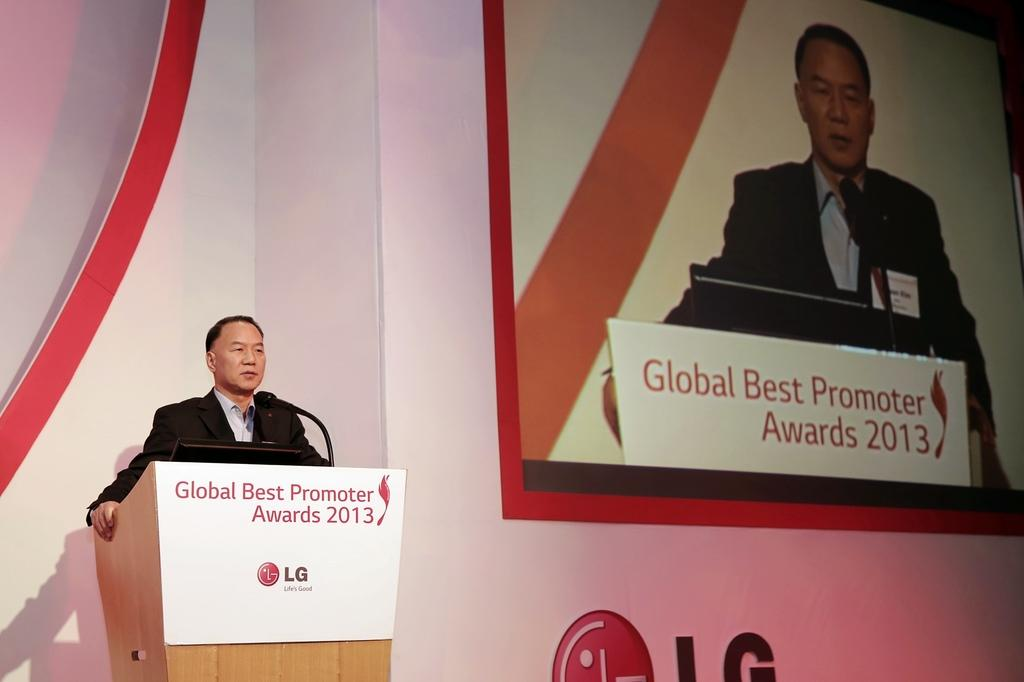Who is the main subject in the image? There is a man in the image. What is the man doing in the image? The man is standing near a podium and speaking through a microphone. What can be seen in the background of the image? There is a screen on the wall in the background of the image. How many fingers is the man using to hold the flag in the image? There is no flag present in the image, and therefore no fingers are being used to hold it. What is the man's digestive system like in the image? The image does not provide any information about the man's digestive system. 